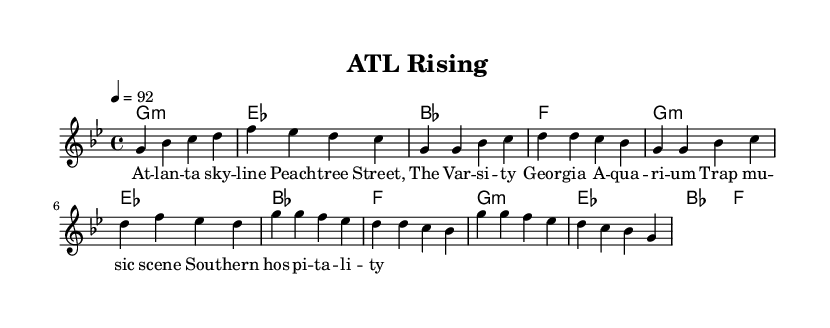What is the key signature of this music? The key signature is G minor, which has two flats (B flat and E flat). It's indicated at the beginning of the score, showing the relevant accidentals.
Answer: G minor What is the time signature of this music? The time signature is 4/4, meaning there are four beats in each measure and the quarter note receives one beat. It is clearly marked at the start of the score.
Answer: 4/4 What is the tempo marking of this music? The tempo marking is 92 beats per minute, specified as "4 = 92", meaning there are 92 quarter note beats per minute, guiding the speed of the piece.
Answer: 92 How many measures are in the chorus section? The chorus section consists of four measures, which can be counted directly from the sheet music. The musical notation in that section indicates four distinct groupings with each group representing a measure.
Answer: 4 What is the last note of the melody in the verse? The last note of the melody in the verse is D, shown in the final measure of that section on the score. By looking at the melody line specifically in the verse, you can see that the very last note corresponds to a D.
Answer: D Which line represents the melody in the score? The melody is represented by the "lead" voice line in the score, which is specifically labeled as "lead" and features the notes above the chord changes. This differentiates it from the other musical components like chords.
Answer: Lead 